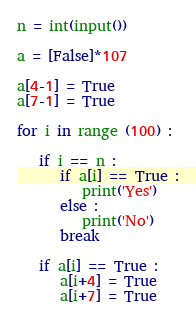Convert code to text. <code><loc_0><loc_0><loc_500><loc_500><_Python_>n = int(input())

a = [False]*107

a[4-1] = True
a[7-1] = True

for i in range (100) :

   if i == n :
      if a[i] == True :
         print('Yes')
      else :
         print('No')
      break

   if a[i] == True :
      a[i+4] = True
      a[i+7] = True</code> 